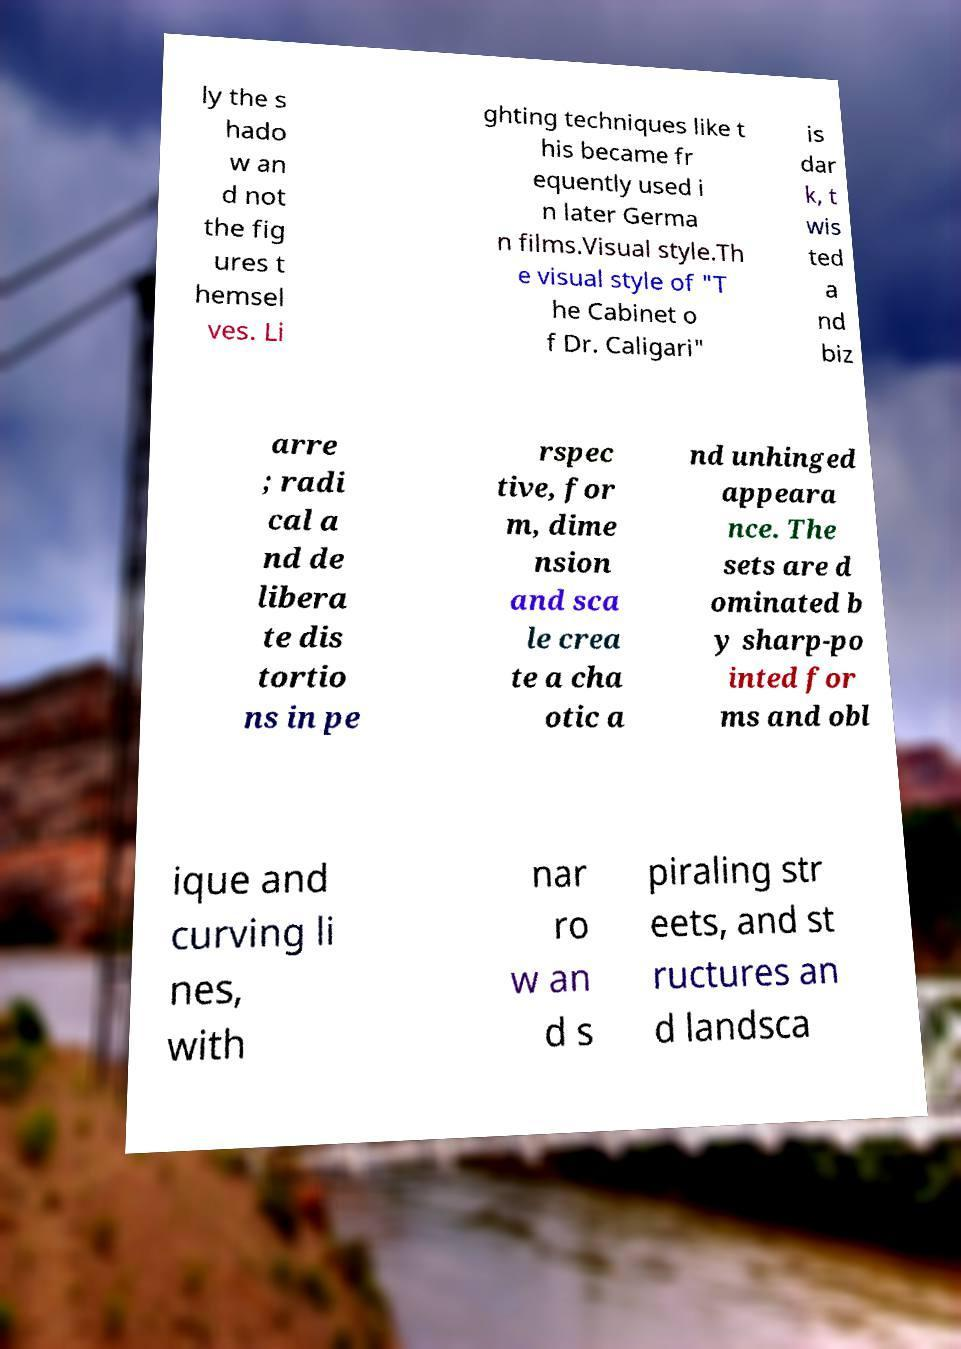Could you assist in decoding the text presented in this image and type it out clearly? ly the s hado w an d not the fig ures t hemsel ves. Li ghting techniques like t his became fr equently used i n later Germa n films.Visual style.Th e visual style of "T he Cabinet o f Dr. Caligari" is dar k, t wis ted a nd biz arre ; radi cal a nd de libera te dis tortio ns in pe rspec tive, for m, dime nsion and sca le crea te a cha otic a nd unhinged appeara nce. The sets are d ominated b y sharp-po inted for ms and obl ique and curving li nes, with nar ro w an d s piraling str eets, and st ructures an d landsca 